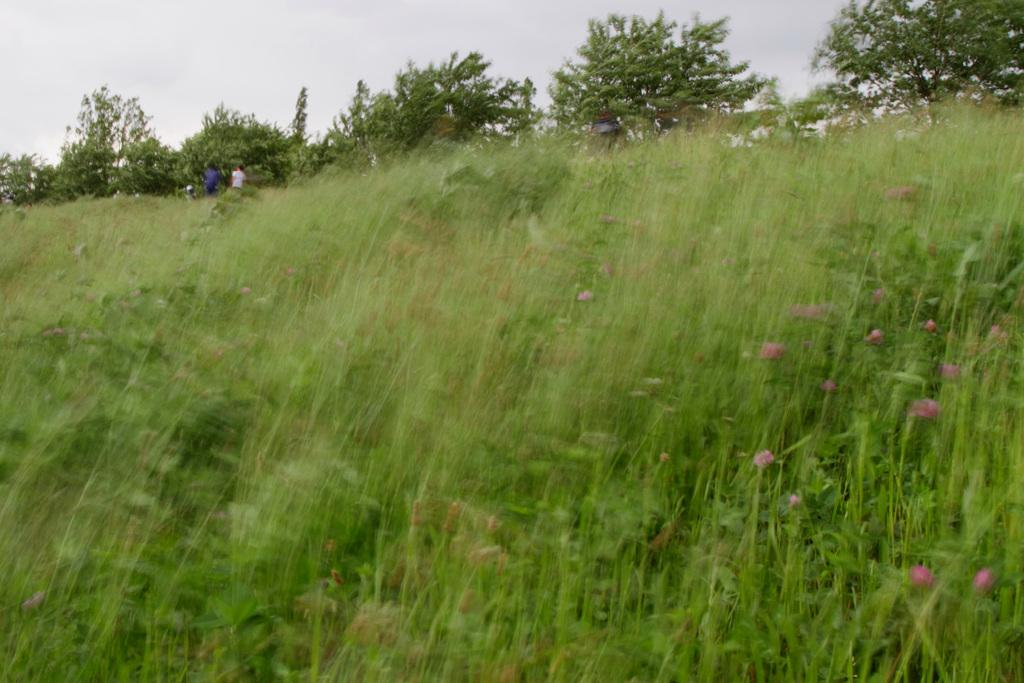What type of vegetation is present in the image? There is grass in the image. What color are the flowers in the image? The flowers in the image are pink. Can you describe the people in the background of the image? There are two persons in the background of the image. What else can be seen in the background of the image? There are trees in the background of the image. What is visible above the grass and trees in the image? The sky is visible in the image. What type of crime is being committed in the image? There is no indication of any crime being committed in the image. How much wealth is visible in the image? There is no indication of any wealth being displayed in the image. 